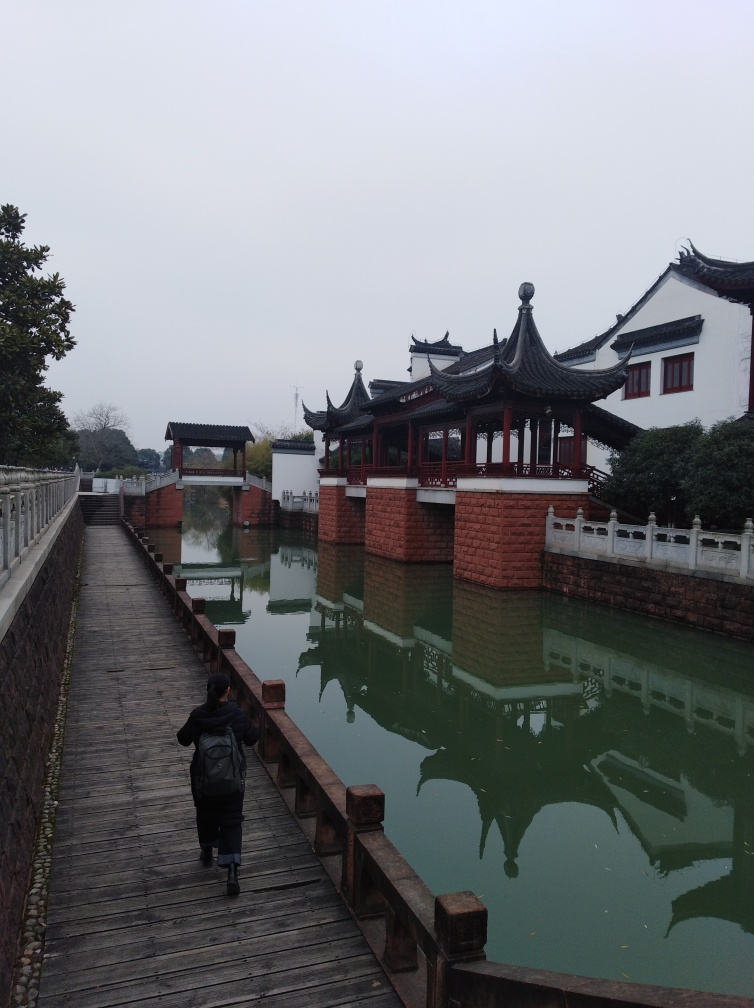What is the focus like in the image?
A. Accurate
B. Out of focus
C. Fuzzy
Answer with the option's letter from the given choices directly.
 A. 